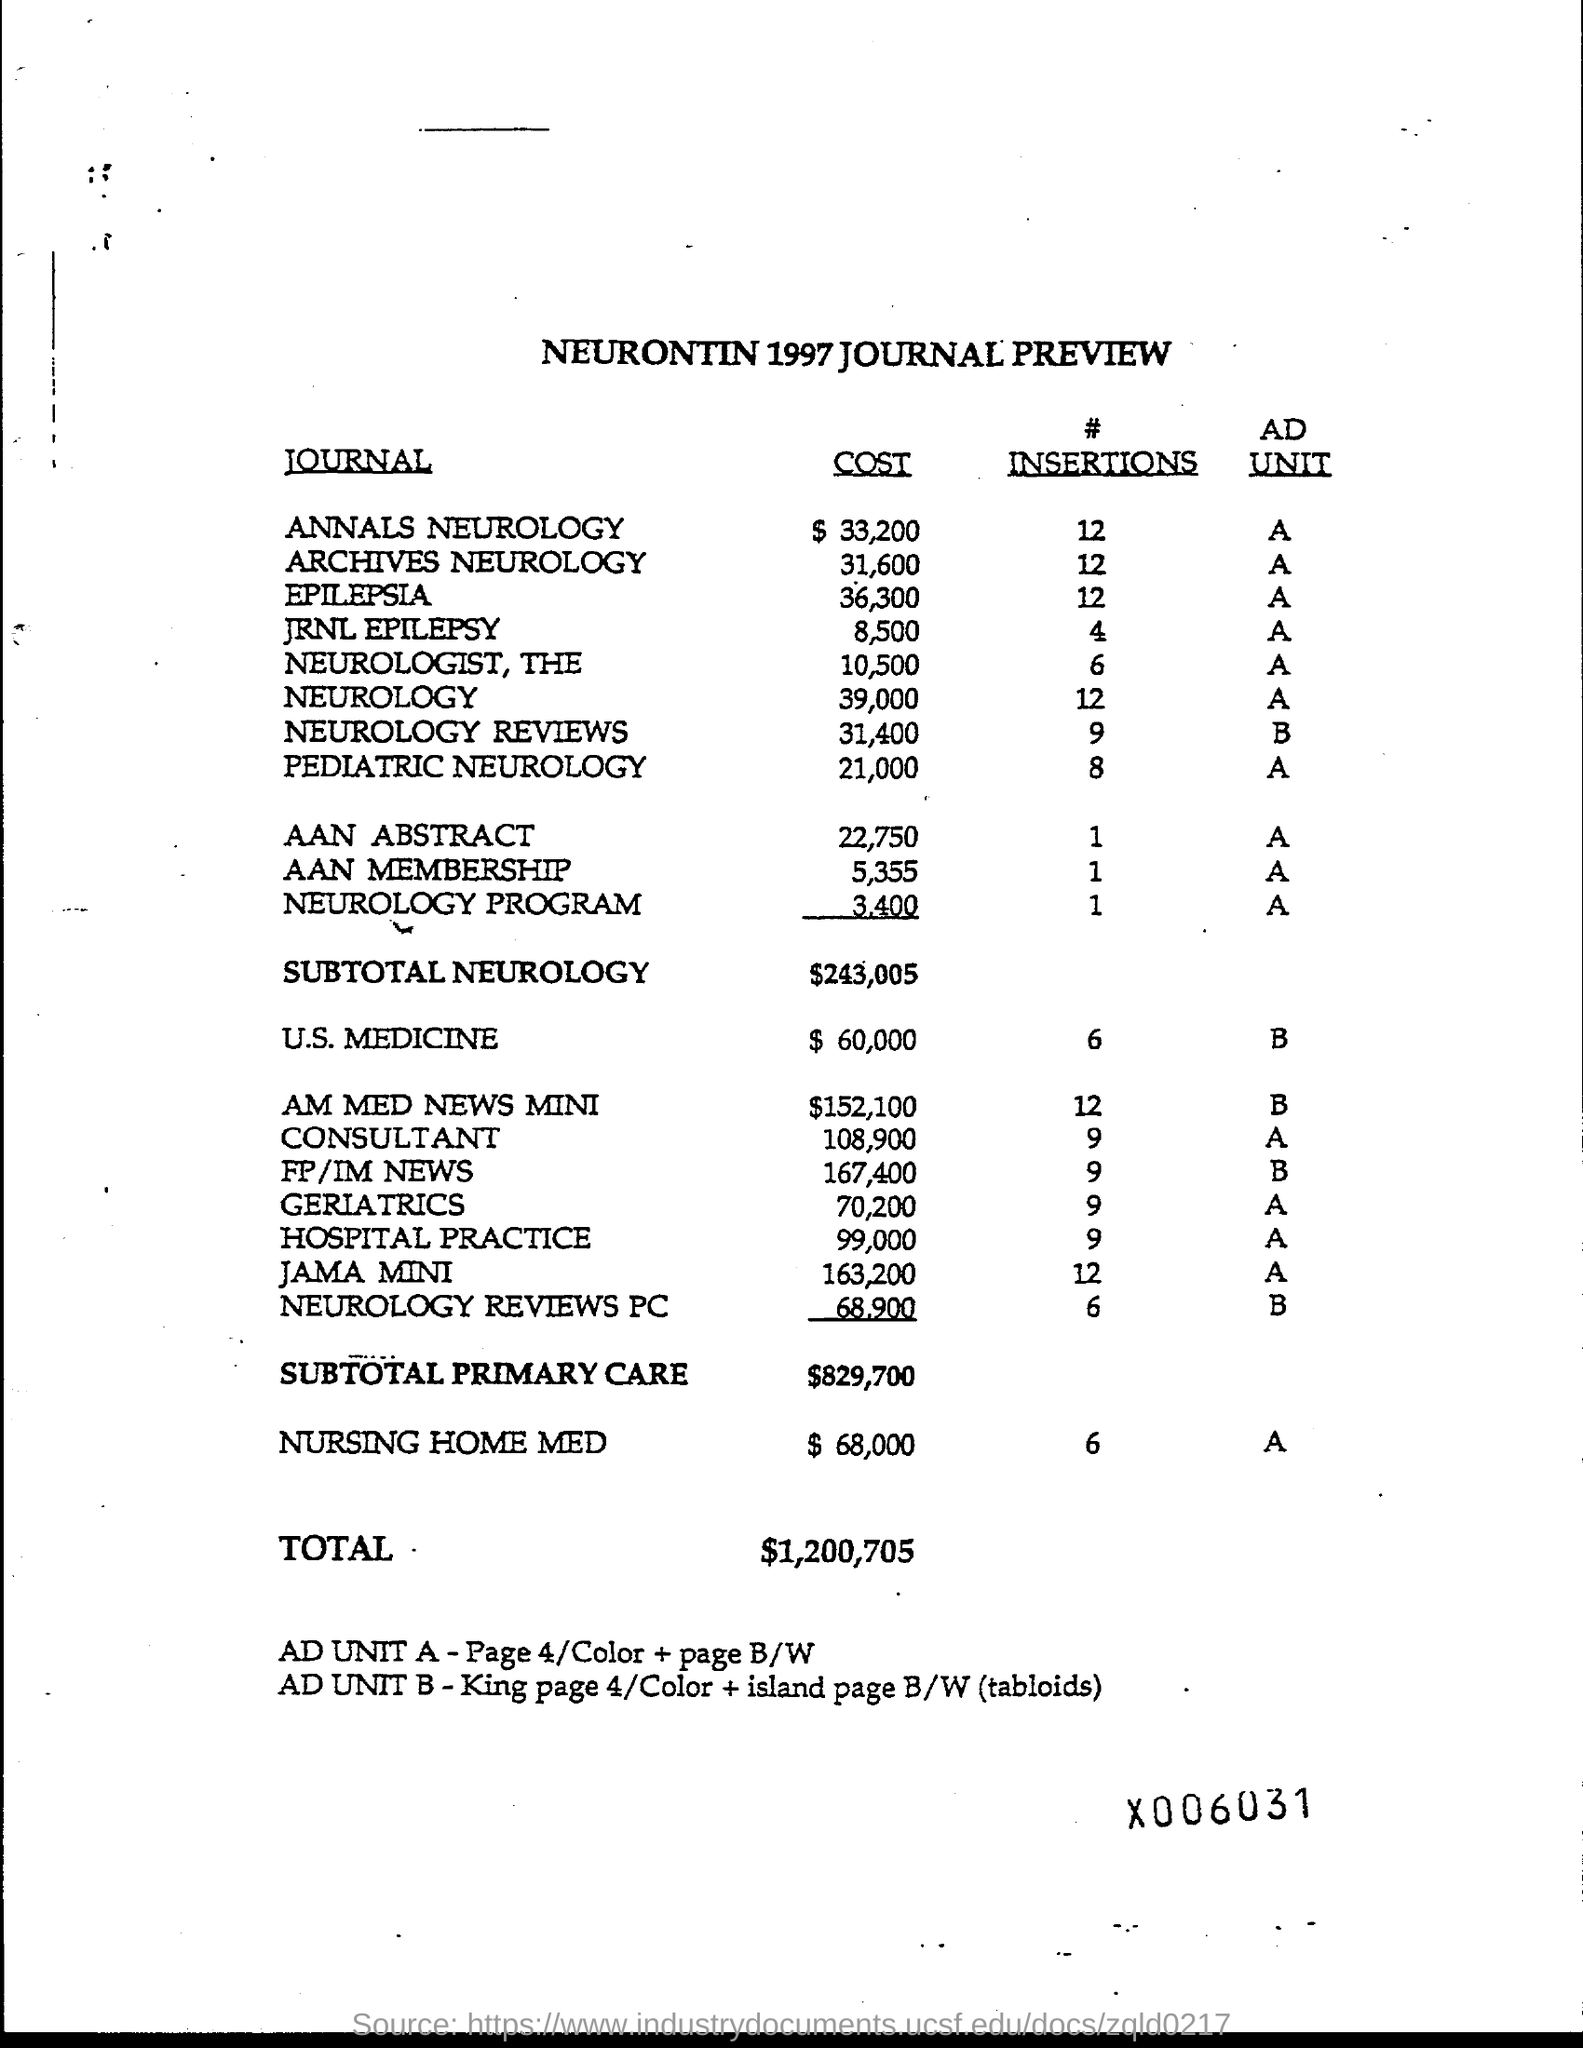Mention a couple of crucial points in this snapshot. The cost of Annals Neurology is approximately $33,200. The cost of Archives Neurology is approximately 31,600. The cost of JRNL epilepsy is currently estimated to be approximately $8,500. The total amount is $1,200,705. The cost of the Neurology Program is 3,400. 